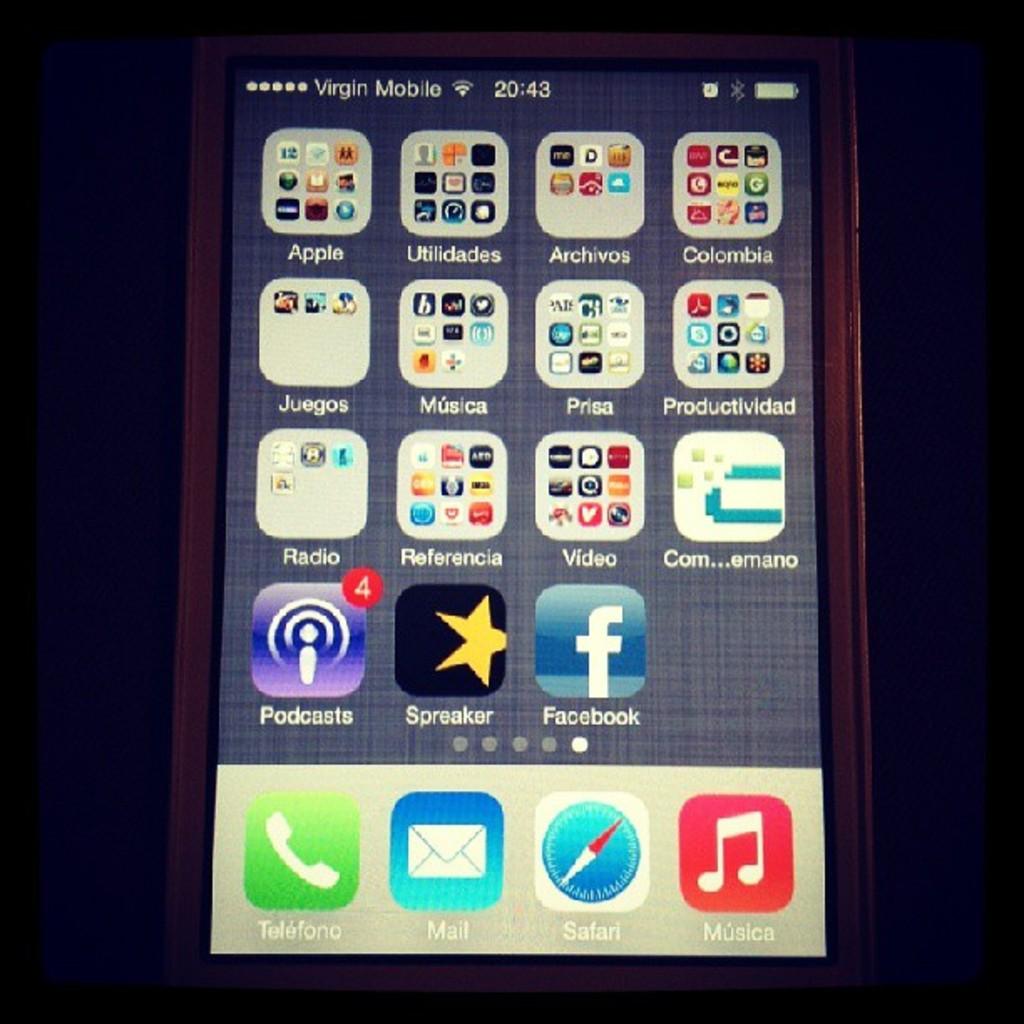What type of smart phone is this?
Ensure brevity in your answer.  Iphone. 